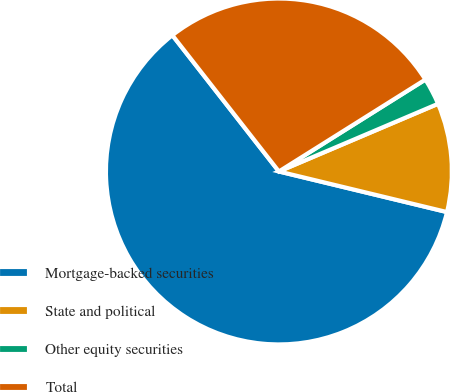Convert chart to OTSL. <chart><loc_0><loc_0><loc_500><loc_500><pie_chart><fcel>Mortgage-backed securities<fcel>State and political<fcel>Other equity securities<fcel>Total<nl><fcel>60.66%<fcel>10.17%<fcel>2.52%<fcel>26.64%<nl></chart> 